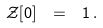Convert formula to latex. <formula><loc_0><loc_0><loc_500><loc_500>\mathcal { Z } [ 0 ] \ = \ 1 \, .</formula> 